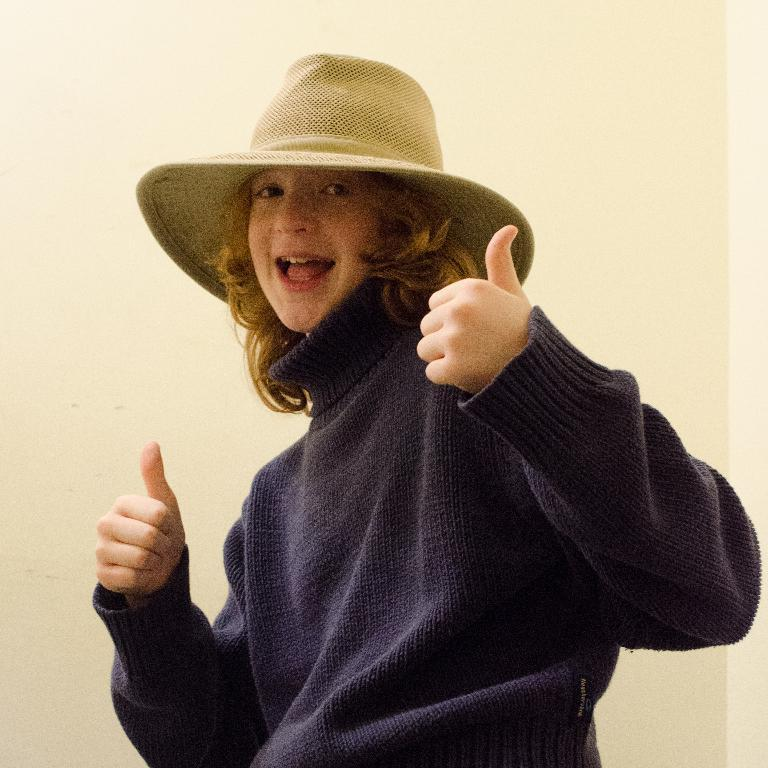What is the main subject of the image? The main subject of the image is a woman. What type of clothing is the woman wearing? The woman is wearing a sweater. What type of accessory is the woman wearing on her head? The woman is wearing a hat. What type of brain can be seen in the image? There is no brain present in the image; it features a woman wearing a sweater and a hat. What type of lamp is visible in the image? There is no lamp present in the image. 